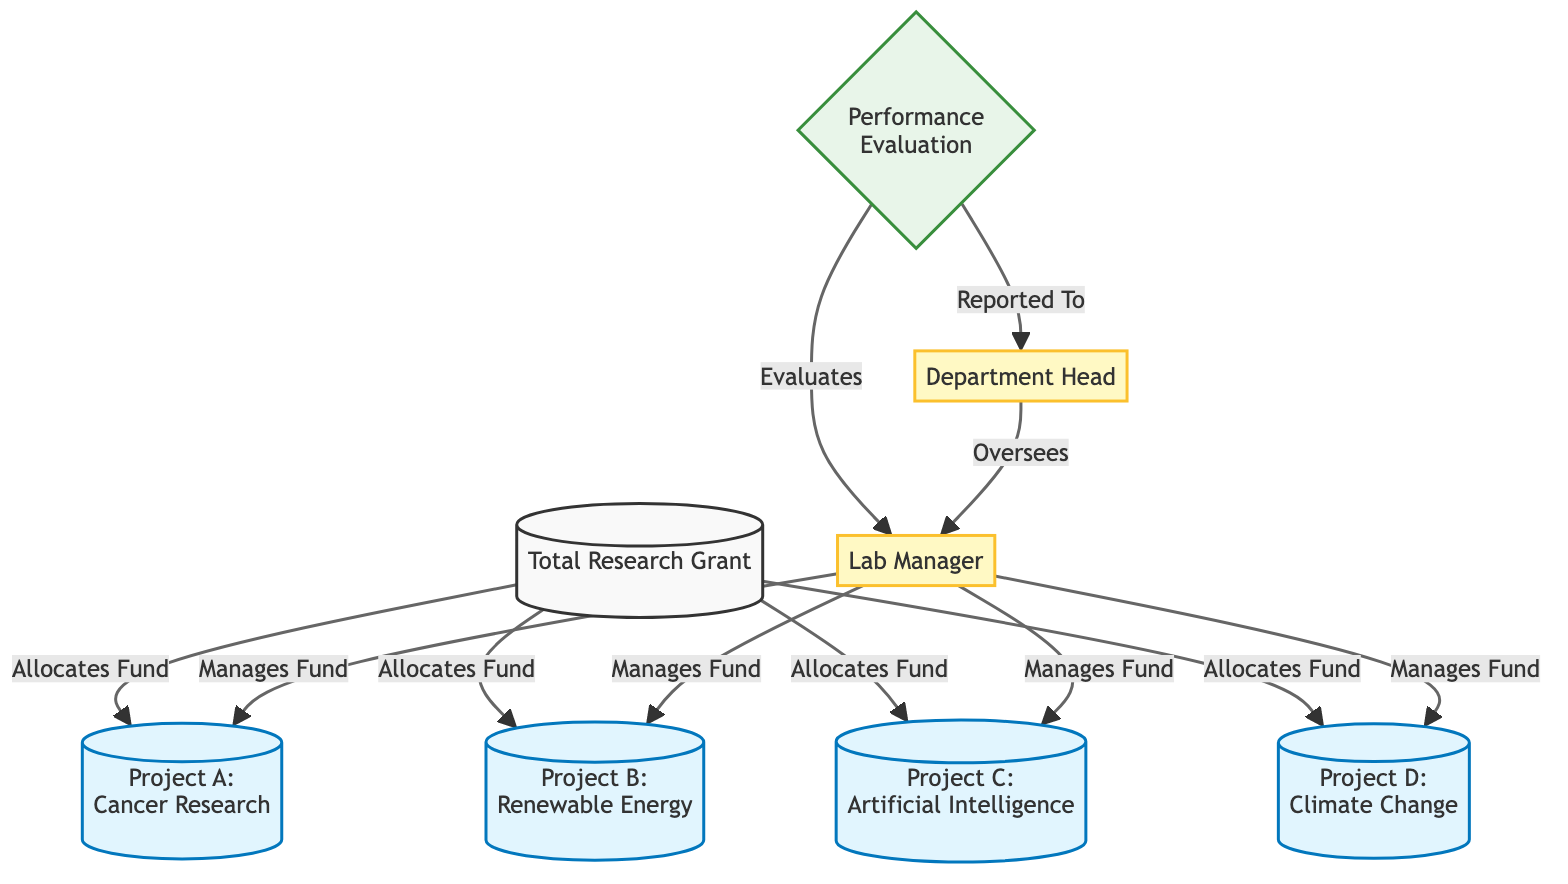What is the total research grant? The diagram starts with a node labeled "Total Research Grant," which indicates the beginning of the diagram without specifying a numerical value.
Answer: Total Research Grant How many projects are listed in the diagram? There are four projects shown which are Project A, Project B, Project C, and Project D. They are the nodes connected to the "Total Research Grant." Counting these gives a total of four.
Answer: 4 Which project is related to artificial intelligence? The diagram clearly labels Project C as "Artificial Intelligence." Therefore, Project C is the one related to artificial intelligence.
Answer: Project C Who manages the funds for the projects? The "Lab Manager" is the person managing the funds, as indicated by the connection lines from the "Lab Manager" node to each project node.
Answer: Lab Manager What relationship does the department head have with the lab manager? The diagram indicates that the "Department Head" oversees the "Lab Manager," shown by a directed edge flowing from the Department Head to the Lab Manager.
Answer: Oversees How many connections are there from the total research grant to the projects? There are four arrows indicating allocations from the "Total Research Grant" to each of the four projects, so there are a total of four connections.
Answer: 4 Which project concerns renewable energy? The diagram indicates that Project B is labeled "Renewable Energy," clearly showing its focus.
Answer: Project B What is the function of the performance evaluation node? The “Performance Evaluation” node connects the "Lab Manager" and the "Department Head," indicating it serves to evaluate the performance of the lab manager.
Answer: Evaluates What type of evaluation is indicated in the diagram? The diagram shows a performance evaluation, indicated by the node labeled "Performance Evaluation." Thus, the type of evaluation is performance.
Answer: Performance Evaluation 